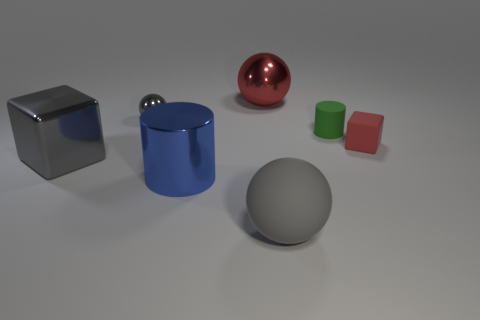Add 2 tiny spheres. How many objects exist? 9 Subtract all metallic balls. How many balls are left? 1 Subtract all red balls. How many balls are left? 2 Subtract 1 cylinders. How many cylinders are left? 1 Subtract all brown cylinders. How many gray spheres are left? 2 Subtract all red metallic spheres. Subtract all tiny red rubber objects. How many objects are left? 5 Add 4 green rubber cylinders. How many green rubber cylinders are left? 5 Add 6 tiny cylinders. How many tiny cylinders exist? 7 Subtract 1 red blocks. How many objects are left? 6 Subtract all balls. How many objects are left? 4 